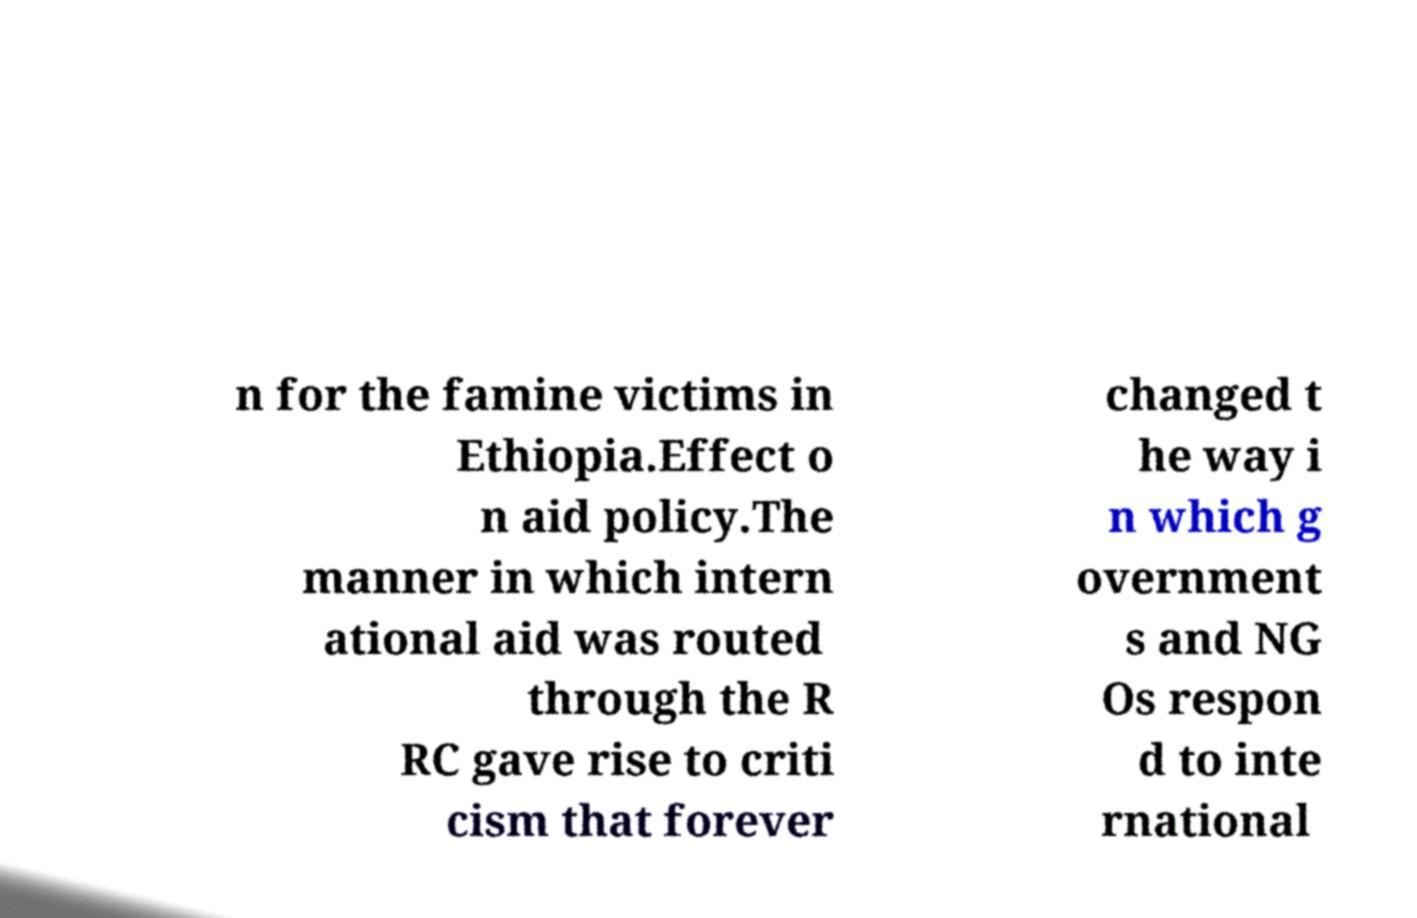Please read and relay the text visible in this image. What does it say? n for the famine victims in Ethiopia.Effect o n aid policy.The manner in which intern ational aid was routed through the R RC gave rise to criti cism that forever changed t he way i n which g overnment s and NG Os respon d to inte rnational 